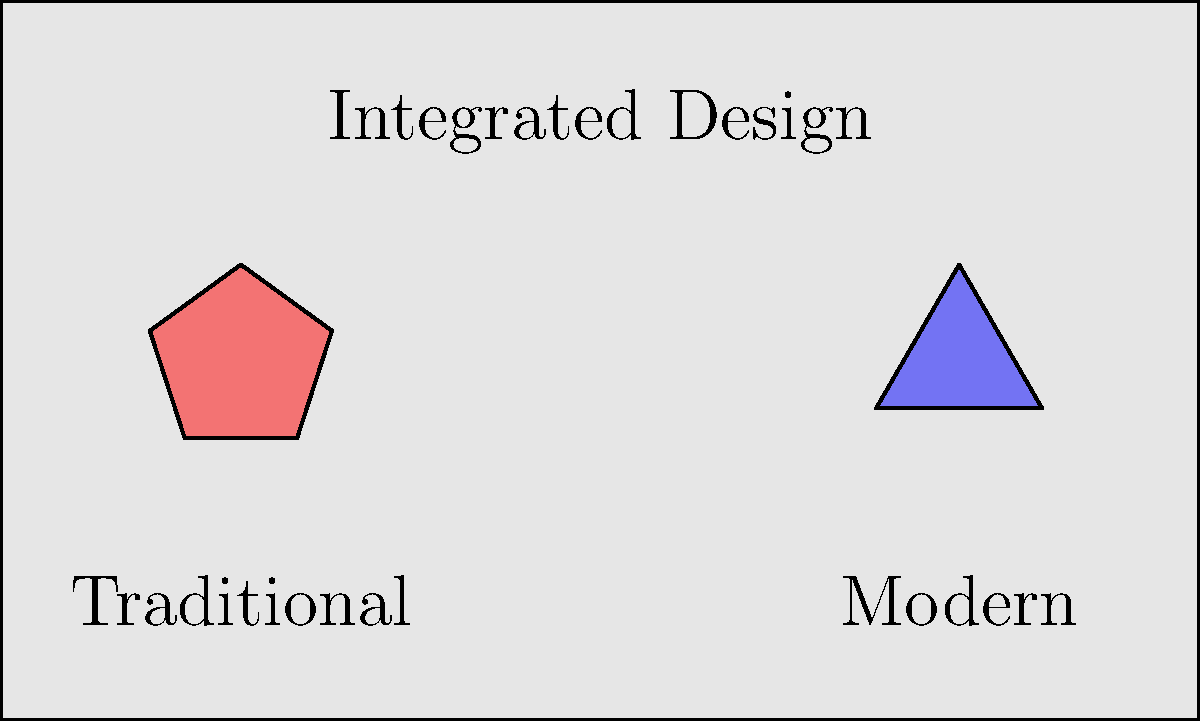In a contemporary office building project, you're tasked with integrating traditional cultural ceiling motifs into a modern design. The client wants to maintain a balance between cultural heritage and contemporary aesthetics. Given the diagram showing a traditional pentagonal motif and a modern triangular design, how would you approach combining these elements to create a cohesive ceiling pattern that respects both cultural significance and modern sensibilities? To integrate culturally significant architectural elements into contemporary ceiling designs, follow these steps:

1. Analyze the traditional motif:
   - Identify the pentagonal shape and its cultural significance
   - Note the symmetry and complexity of the traditional design

2. Examine the modern design:
   - Observe the simplicity of the triangular shape
   - Recognize its contemporary appeal and clean lines

3. Find common ground:
   - Both shapes are polygons, allowing for geometric integration
   - The number of sides can be used as a basis for a new pattern

4. Create a fusion design:
   - Combine the pentagon and triangle to form a new shape
   - For example, create a pentagonal outline with triangular divisions inside

5. Apply color theory:
   - Use a color palette that respects both traditional and modern aesthetics
   - Implement opacity variations to create depth and visual interest

6. Consider scale and repetition:
   - Determine the appropriate size for the new motif
   - Design a repeating pattern that flows across the ceiling

7. Incorporate modern materials:
   - Select materials that complement both traditional and contemporary elements
   - Consider using lightweight, sustainable options for ease of installation

8. Integrate lighting:
   - Incorporate LED lighting to highlight the design's features
   - Use programmable lighting to allow for dynamic color changes

9. Ensure balance:
   - Maintain a 50/50 ratio of traditional to modern elements
   - Create focal points that draw attention to both aspects of the design

10. Respect cultural significance:
    - Research the meaning behind the traditional motif
    - Ensure the new design doesn't compromise its cultural integrity

By following these steps, you create a ceiling design that seamlessly blends cultural heritage with contemporary aesthetics, resulting in a unique and meaningful architectural element.
Answer: Geometric fusion of pentagonal and triangular motifs, balanced color palette, modern materials, integrated lighting 